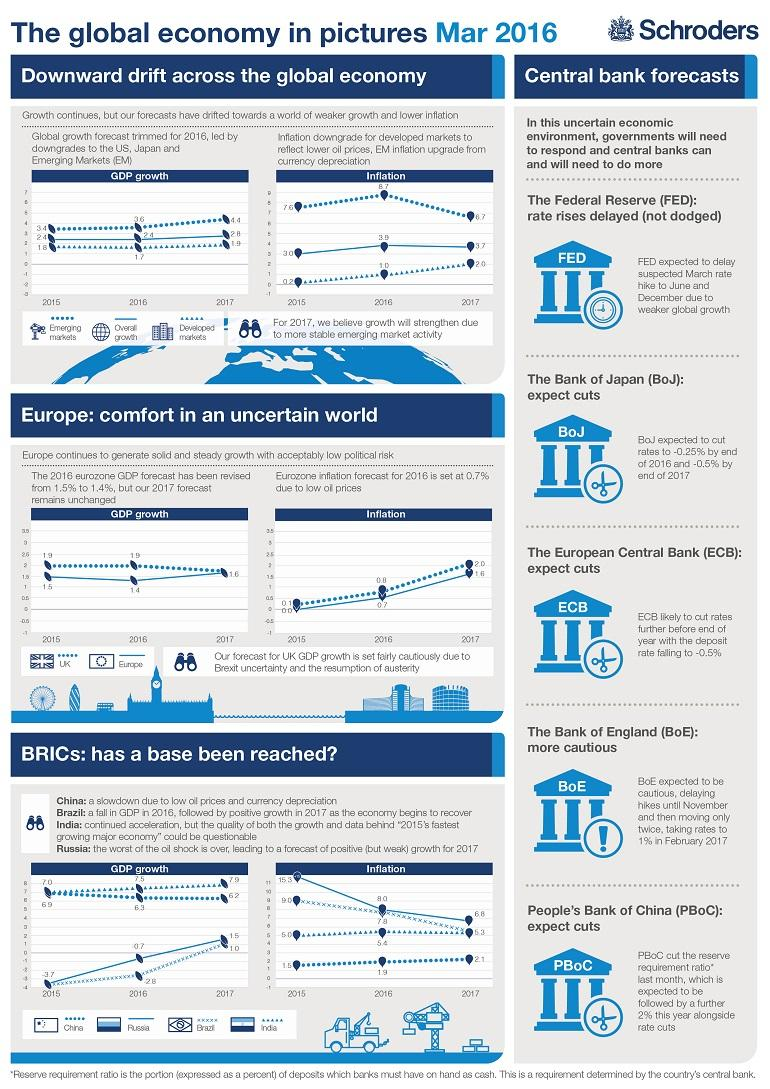Specify some key components in this picture. GDP has been demonstrated to be relevant in two distinct markets in the global economy: emerging markets and developed markets. The inflation rate in Brazil has decreased significantly from 2015 to 2017, from 3.7% to approximately 3.5%. In 2016, the rate of inflation in developed markets was 1.0%. India, a member country of the BRICS group, has exhibited the most stable inflation rates between 2015 and 2017. BRICS is a group of countries consisting of Brazil, Russia, India, China, and South Africa, with the exception of India. 